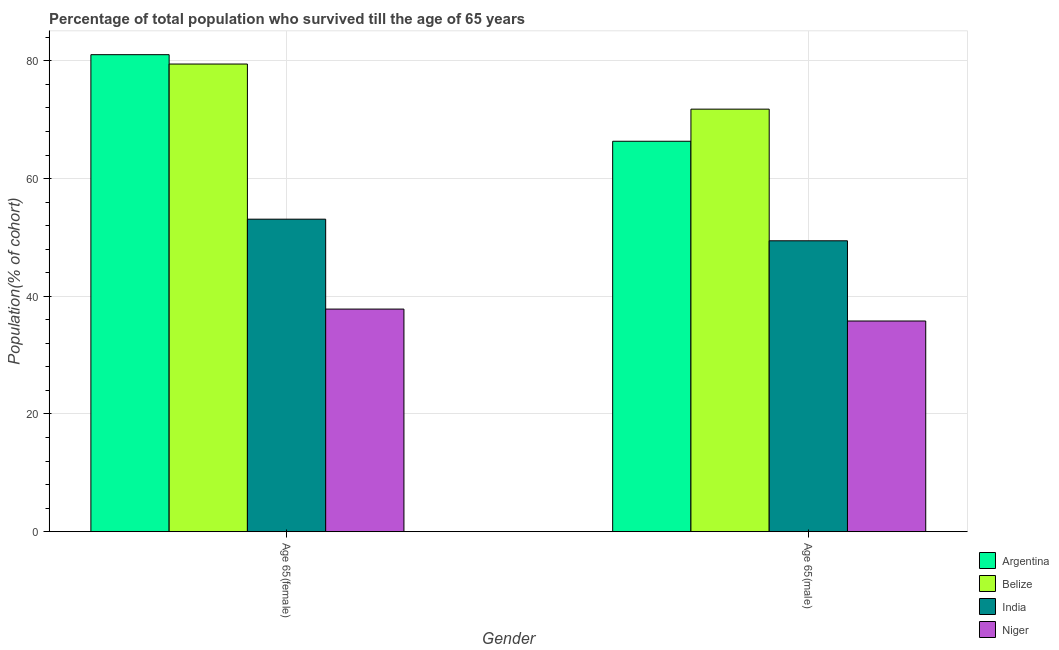How many different coloured bars are there?
Provide a succinct answer. 4. How many groups of bars are there?
Your response must be concise. 2. Are the number of bars on each tick of the X-axis equal?
Offer a terse response. Yes. How many bars are there on the 2nd tick from the right?
Ensure brevity in your answer.  4. What is the label of the 1st group of bars from the left?
Offer a terse response. Age 65(female). What is the percentage of male population who survived till age of 65 in Niger?
Provide a short and direct response. 35.8. Across all countries, what is the maximum percentage of female population who survived till age of 65?
Offer a terse response. 81.05. Across all countries, what is the minimum percentage of female population who survived till age of 65?
Ensure brevity in your answer.  37.82. In which country was the percentage of male population who survived till age of 65 maximum?
Offer a very short reply. Belize. In which country was the percentage of male population who survived till age of 65 minimum?
Your answer should be very brief. Niger. What is the total percentage of female population who survived till age of 65 in the graph?
Make the answer very short. 251.43. What is the difference between the percentage of male population who survived till age of 65 in Belize and that in Niger?
Offer a terse response. 35.99. What is the difference between the percentage of female population who survived till age of 65 in Argentina and the percentage of male population who survived till age of 65 in India?
Offer a terse response. 31.62. What is the average percentage of female population who survived till age of 65 per country?
Make the answer very short. 62.86. What is the difference between the percentage of female population who survived till age of 65 and percentage of male population who survived till age of 65 in India?
Make the answer very short. 3.67. What is the ratio of the percentage of male population who survived till age of 65 in India to that in Niger?
Your answer should be very brief. 1.38. Is the percentage of male population who survived till age of 65 in Argentina less than that in Niger?
Keep it short and to the point. No. In how many countries, is the percentage of female population who survived till age of 65 greater than the average percentage of female population who survived till age of 65 taken over all countries?
Ensure brevity in your answer.  2. What does the 2nd bar from the left in Age 65(female) represents?
Offer a terse response. Belize. What does the 3rd bar from the right in Age 65(female) represents?
Keep it short and to the point. Belize. How many countries are there in the graph?
Keep it short and to the point. 4. Are the values on the major ticks of Y-axis written in scientific E-notation?
Provide a short and direct response. No. Where does the legend appear in the graph?
Make the answer very short. Bottom right. How are the legend labels stacked?
Offer a very short reply. Vertical. What is the title of the graph?
Offer a very short reply. Percentage of total population who survived till the age of 65 years. Does "Poland" appear as one of the legend labels in the graph?
Your response must be concise. No. What is the label or title of the Y-axis?
Give a very brief answer. Population(% of cohort). What is the Population(% of cohort) of Argentina in Age 65(female)?
Your answer should be very brief. 81.05. What is the Population(% of cohort) in Belize in Age 65(female)?
Offer a very short reply. 79.46. What is the Population(% of cohort) in India in Age 65(female)?
Provide a short and direct response. 53.1. What is the Population(% of cohort) of Niger in Age 65(female)?
Make the answer very short. 37.82. What is the Population(% of cohort) of Argentina in Age 65(male)?
Provide a short and direct response. 66.34. What is the Population(% of cohort) of Belize in Age 65(male)?
Make the answer very short. 71.79. What is the Population(% of cohort) in India in Age 65(male)?
Your answer should be very brief. 49.43. What is the Population(% of cohort) in Niger in Age 65(male)?
Your answer should be very brief. 35.8. Across all Gender, what is the maximum Population(% of cohort) of Argentina?
Your response must be concise. 81.05. Across all Gender, what is the maximum Population(% of cohort) of Belize?
Keep it short and to the point. 79.46. Across all Gender, what is the maximum Population(% of cohort) in India?
Give a very brief answer. 53.1. Across all Gender, what is the maximum Population(% of cohort) in Niger?
Offer a terse response. 37.82. Across all Gender, what is the minimum Population(% of cohort) of Argentina?
Give a very brief answer. 66.34. Across all Gender, what is the minimum Population(% of cohort) in Belize?
Ensure brevity in your answer.  71.79. Across all Gender, what is the minimum Population(% of cohort) in India?
Provide a succinct answer. 49.43. Across all Gender, what is the minimum Population(% of cohort) of Niger?
Make the answer very short. 35.8. What is the total Population(% of cohort) of Argentina in the graph?
Provide a short and direct response. 147.39. What is the total Population(% of cohort) in Belize in the graph?
Offer a very short reply. 151.25. What is the total Population(% of cohort) of India in the graph?
Provide a short and direct response. 102.53. What is the total Population(% of cohort) of Niger in the graph?
Make the answer very short. 73.62. What is the difference between the Population(% of cohort) in Argentina in Age 65(female) and that in Age 65(male)?
Give a very brief answer. 14.71. What is the difference between the Population(% of cohort) of Belize in Age 65(female) and that in Age 65(male)?
Keep it short and to the point. 7.67. What is the difference between the Population(% of cohort) of India in Age 65(female) and that in Age 65(male)?
Your response must be concise. 3.67. What is the difference between the Population(% of cohort) of Niger in Age 65(female) and that in Age 65(male)?
Your response must be concise. 2.03. What is the difference between the Population(% of cohort) of Argentina in Age 65(female) and the Population(% of cohort) of Belize in Age 65(male)?
Your answer should be very brief. 9.26. What is the difference between the Population(% of cohort) of Argentina in Age 65(female) and the Population(% of cohort) of India in Age 65(male)?
Provide a short and direct response. 31.62. What is the difference between the Population(% of cohort) in Argentina in Age 65(female) and the Population(% of cohort) in Niger in Age 65(male)?
Keep it short and to the point. 45.25. What is the difference between the Population(% of cohort) in Belize in Age 65(female) and the Population(% of cohort) in India in Age 65(male)?
Your response must be concise. 30.03. What is the difference between the Population(% of cohort) in Belize in Age 65(female) and the Population(% of cohort) in Niger in Age 65(male)?
Make the answer very short. 43.66. What is the difference between the Population(% of cohort) in India in Age 65(female) and the Population(% of cohort) in Niger in Age 65(male)?
Offer a very short reply. 17.3. What is the average Population(% of cohort) in Argentina per Gender?
Ensure brevity in your answer.  73.69. What is the average Population(% of cohort) of Belize per Gender?
Offer a very short reply. 75.62. What is the average Population(% of cohort) of India per Gender?
Your answer should be compact. 51.26. What is the average Population(% of cohort) in Niger per Gender?
Your response must be concise. 36.81. What is the difference between the Population(% of cohort) of Argentina and Population(% of cohort) of Belize in Age 65(female)?
Give a very brief answer. 1.59. What is the difference between the Population(% of cohort) in Argentina and Population(% of cohort) in India in Age 65(female)?
Keep it short and to the point. 27.95. What is the difference between the Population(% of cohort) in Argentina and Population(% of cohort) in Niger in Age 65(female)?
Ensure brevity in your answer.  43.22. What is the difference between the Population(% of cohort) in Belize and Population(% of cohort) in India in Age 65(female)?
Provide a short and direct response. 26.36. What is the difference between the Population(% of cohort) of Belize and Population(% of cohort) of Niger in Age 65(female)?
Offer a terse response. 41.63. What is the difference between the Population(% of cohort) of India and Population(% of cohort) of Niger in Age 65(female)?
Ensure brevity in your answer.  15.27. What is the difference between the Population(% of cohort) in Argentina and Population(% of cohort) in Belize in Age 65(male)?
Your answer should be compact. -5.45. What is the difference between the Population(% of cohort) in Argentina and Population(% of cohort) in India in Age 65(male)?
Keep it short and to the point. 16.91. What is the difference between the Population(% of cohort) of Argentina and Population(% of cohort) of Niger in Age 65(male)?
Provide a succinct answer. 30.54. What is the difference between the Population(% of cohort) of Belize and Population(% of cohort) of India in Age 65(male)?
Offer a very short reply. 22.36. What is the difference between the Population(% of cohort) in Belize and Population(% of cohort) in Niger in Age 65(male)?
Offer a terse response. 35.99. What is the difference between the Population(% of cohort) in India and Population(% of cohort) in Niger in Age 65(male)?
Provide a succinct answer. 13.63. What is the ratio of the Population(% of cohort) of Argentina in Age 65(female) to that in Age 65(male)?
Offer a terse response. 1.22. What is the ratio of the Population(% of cohort) in Belize in Age 65(female) to that in Age 65(male)?
Your response must be concise. 1.11. What is the ratio of the Population(% of cohort) of India in Age 65(female) to that in Age 65(male)?
Your answer should be very brief. 1.07. What is the ratio of the Population(% of cohort) in Niger in Age 65(female) to that in Age 65(male)?
Ensure brevity in your answer.  1.06. What is the difference between the highest and the second highest Population(% of cohort) in Argentina?
Provide a succinct answer. 14.71. What is the difference between the highest and the second highest Population(% of cohort) of Belize?
Offer a very short reply. 7.67. What is the difference between the highest and the second highest Population(% of cohort) of India?
Give a very brief answer. 3.67. What is the difference between the highest and the second highest Population(% of cohort) of Niger?
Your response must be concise. 2.03. What is the difference between the highest and the lowest Population(% of cohort) of Argentina?
Give a very brief answer. 14.71. What is the difference between the highest and the lowest Population(% of cohort) of Belize?
Your response must be concise. 7.67. What is the difference between the highest and the lowest Population(% of cohort) in India?
Make the answer very short. 3.67. What is the difference between the highest and the lowest Population(% of cohort) of Niger?
Keep it short and to the point. 2.03. 